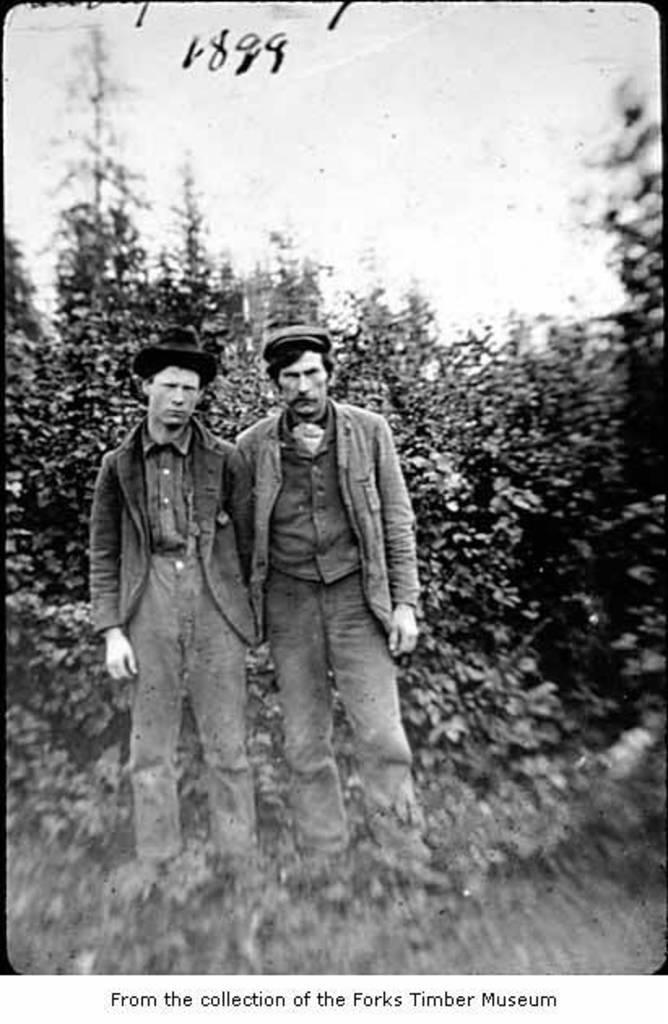What is the color scheme of the image? The image is black and white. How many people are in the image? There are two persons standing in the image. What can be seen behind the persons? There are trees behind the persons. What is visible in the background of the image? The sky is visible in the background of the image. What type of sweater is the person on the left wearing in the image? There is no information about the clothing of the persons in the image, as it is black and white and does not provide details about their attire. 